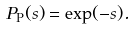<formula> <loc_0><loc_0><loc_500><loc_500>P _ { \text {P} } ( s ) = \exp ( - s ) .</formula> 